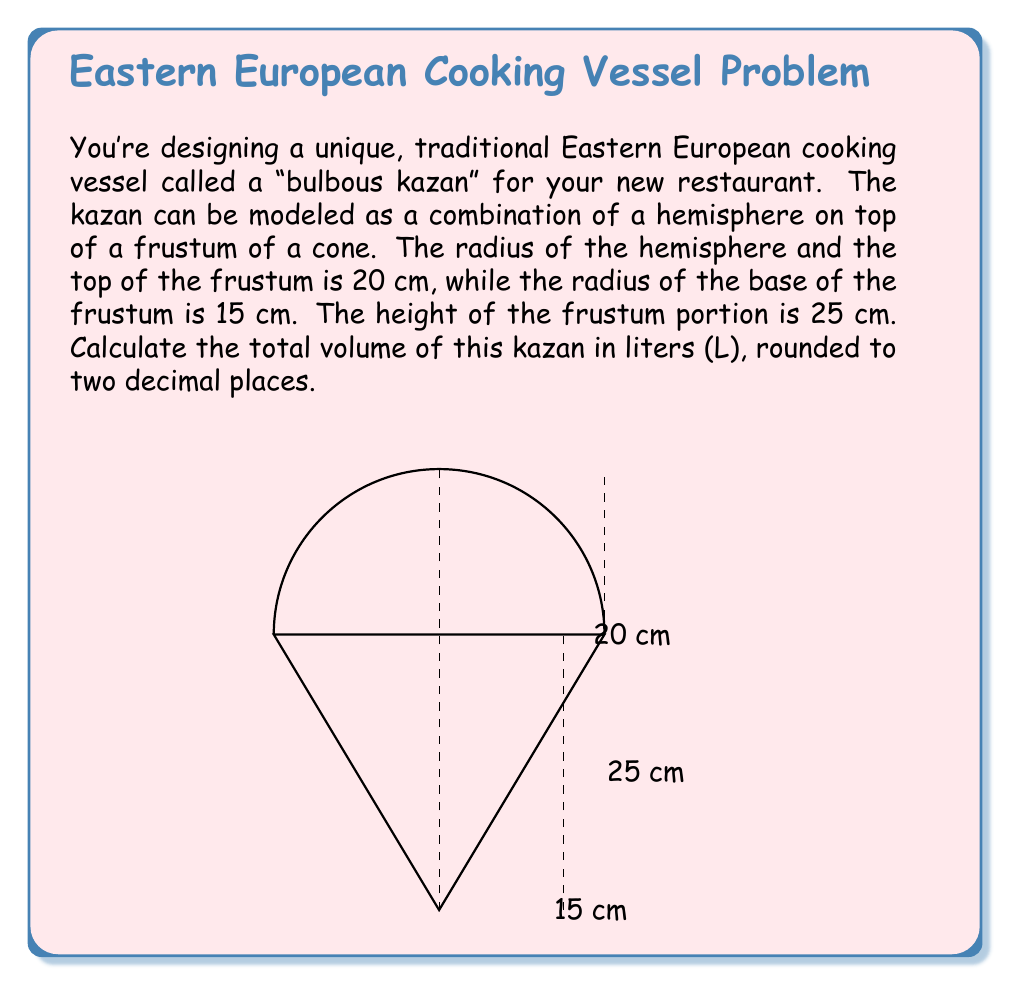Can you solve this math problem? To find the total volume of the kazan, we need to calculate the volumes of the hemisphere and the frustum separately, then add them together.

1. Volume of the hemisphere:
   $$V_h = \frac{2}{3}\pi r^3$$
   where $r = 20$ cm
   $$V_h = \frac{2}{3}\pi (20)^3 = \frac{2}{3}\pi (8000) \approx 16755.16 \text{ cm}^3$$

2. Volume of the frustum:
   $$V_f = \frac{1}{3}\pi h(R^2 + r^2 + Rr)$$
   where $h = 25$ cm, $R = 20$ cm, and $r = 15$ cm
   $$V_f = \frac{1}{3}\pi (25)(20^2 + 15^2 + 20 \cdot 15)$$
   $$V_f = \frac{1}{3}\pi (25)(400 + 225 + 300)$$
   $$V_f = \frac{1}{3}\pi (25)(925) = 24217.39 \text{ cm}^3$$

3. Total volume:
   $$V_t = V_h + V_f = 16755.16 + 24217.39 = 40972.55 \text{ cm}^3$$

4. Convert to liters:
   $$40972.55 \text{ cm}^3 \cdot \frac{1 \text{ L}}{1000 \text{ cm}^3} = 40.97 \text{ L}$$

Rounding to two decimal places, we get 40.97 L.
Answer: 40.97 L 